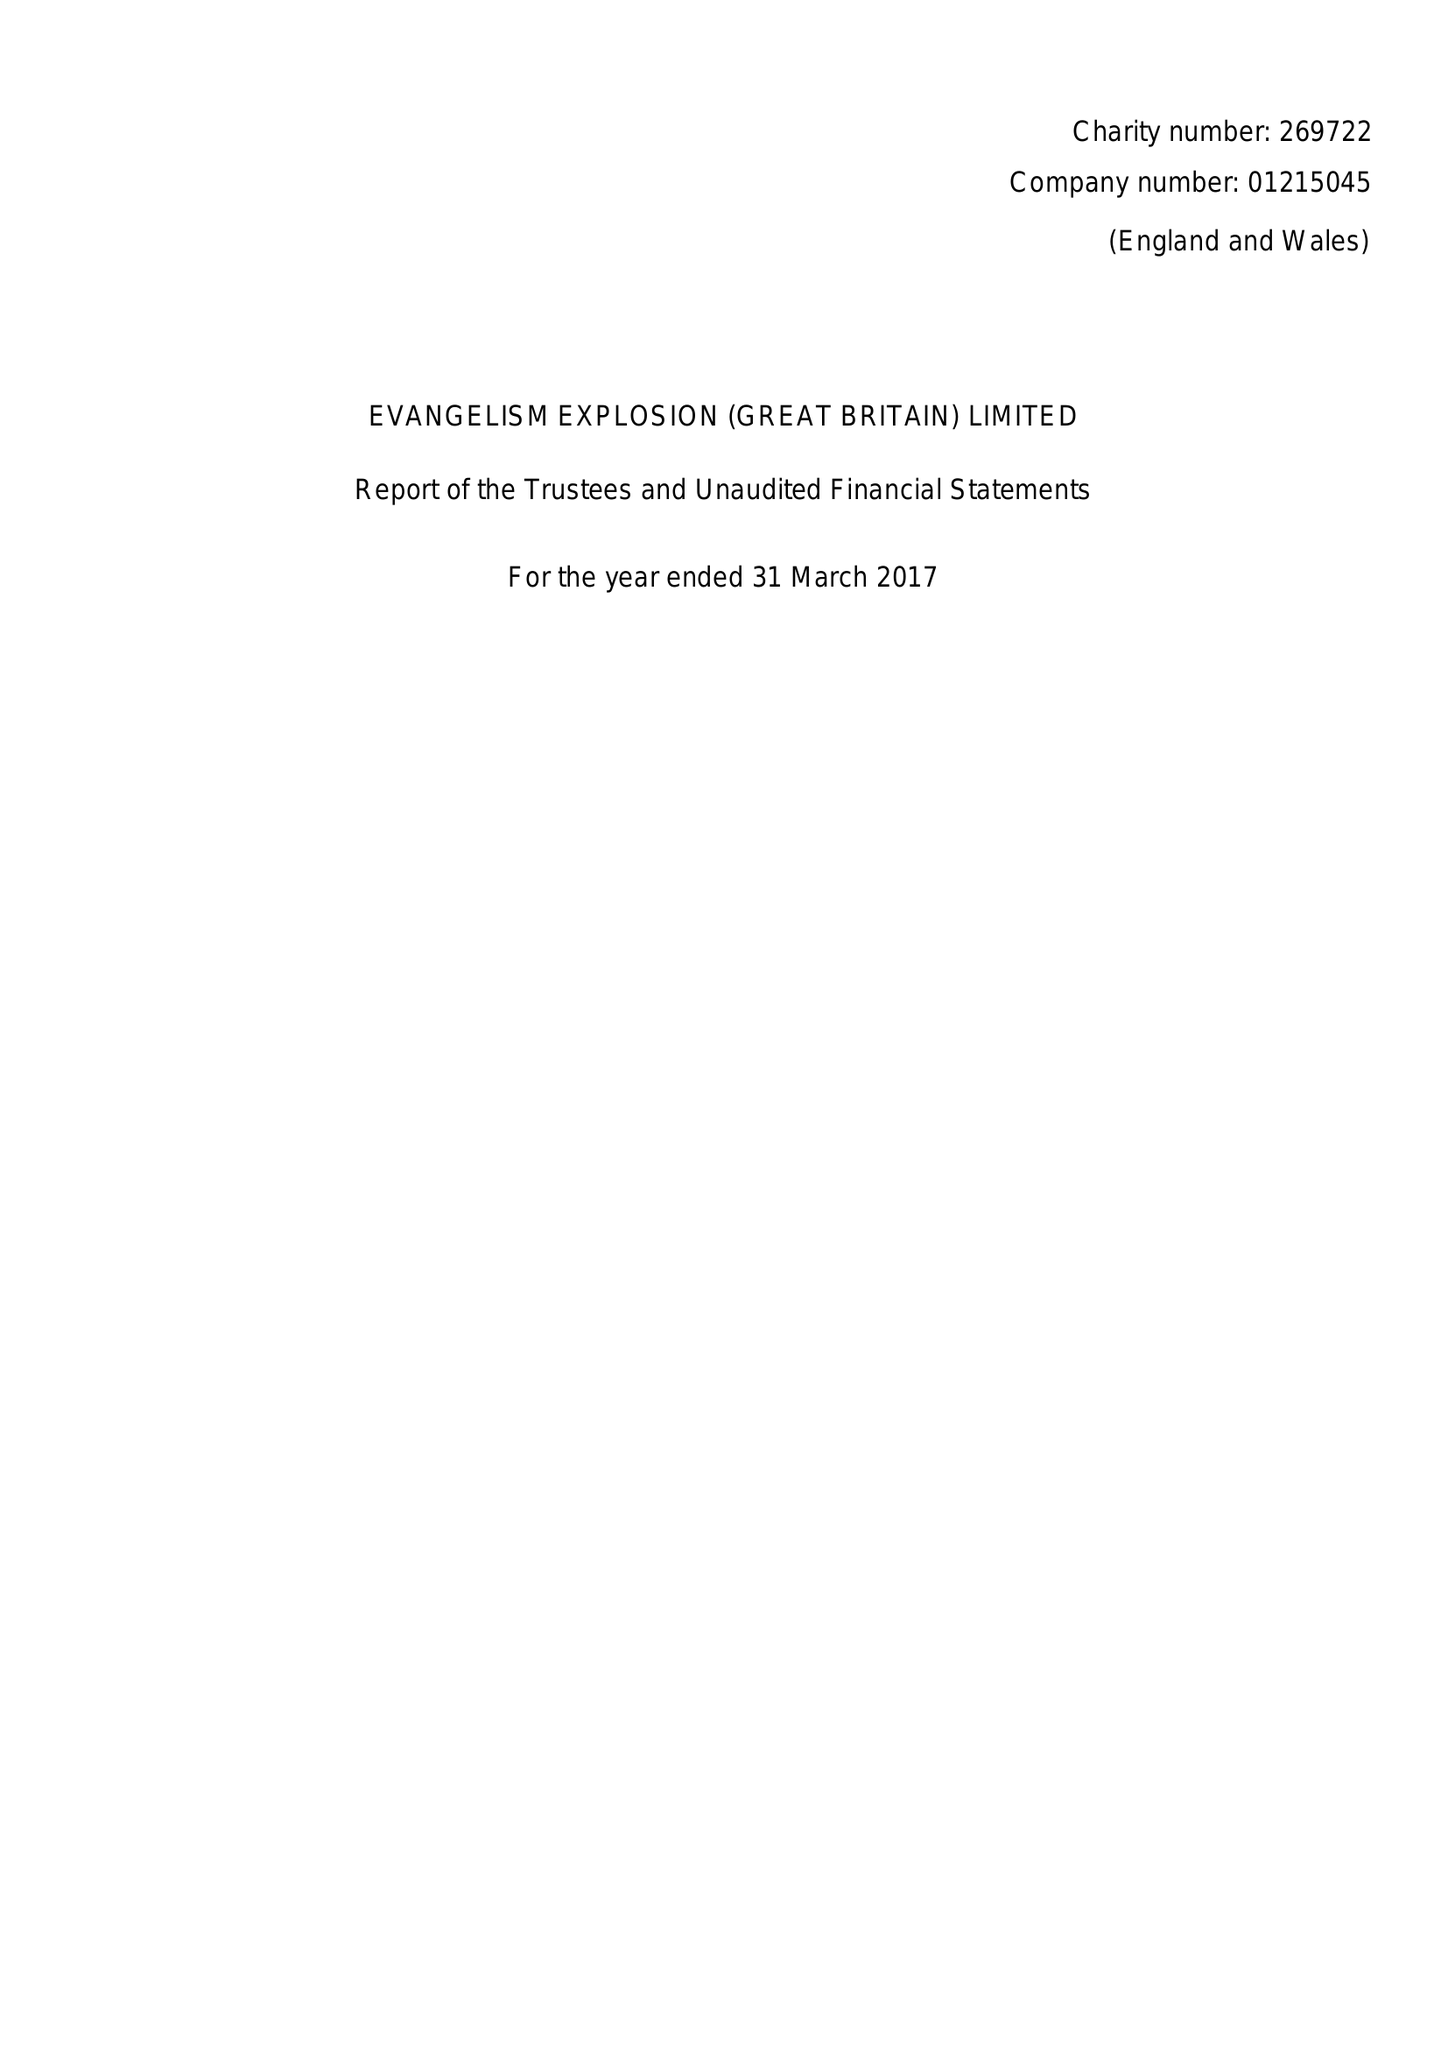What is the value for the income_annually_in_british_pounds?
Answer the question using a single word or phrase. 25967.00 